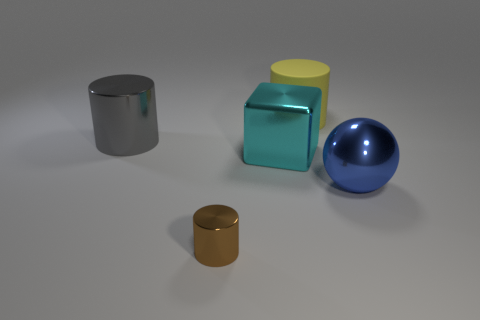Add 2 cyan cubes. How many objects exist? 7 Subtract all cubes. How many objects are left? 4 Add 4 gray shiny objects. How many gray shiny objects exist? 5 Subtract 0 gray balls. How many objects are left? 5 Subtract all small brown rubber cylinders. Subtract all big gray metal cylinders. How many objects are left? 4 Add 5 big blue metal balls. How many big blue metal balls are left? 6 